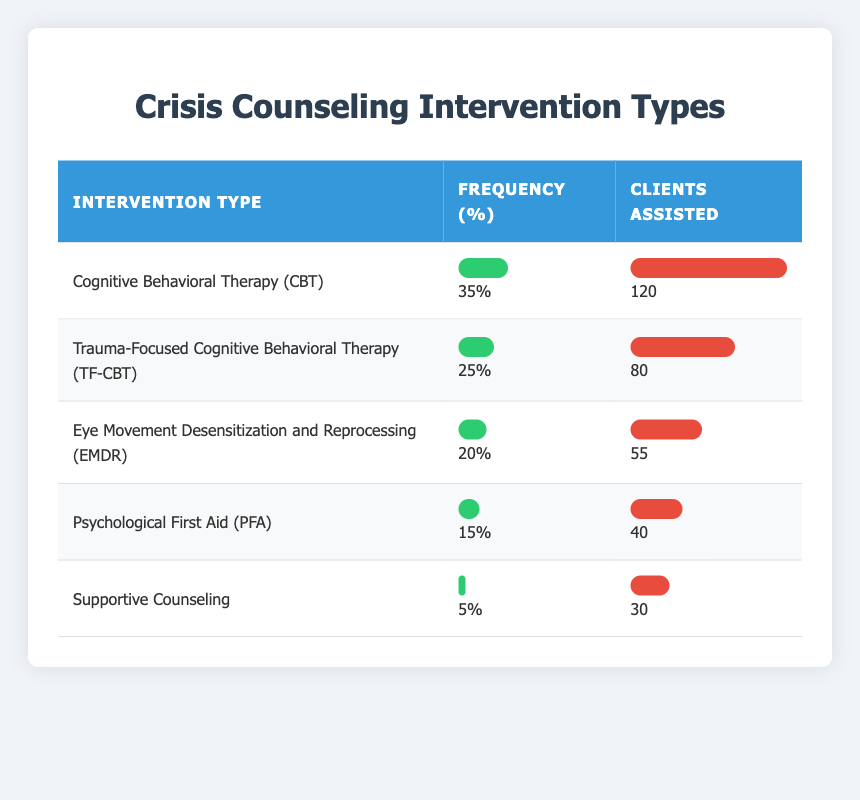What is the most frequently used intervention type? The table shows the frequency of each intervention type. Cognitive Behavioral Therapy (CBT) has the highest frequency of 35%.
Answer: Cognitive Behavioral Therapy (CBT) How many clients were assisted by Eye Movement Desensitization and Reprocessing (EMDR)? The table lists the number of clients assisted for each intervention type. EMDR assisted 55 clients.
Answer: 55 Is Supportive Counseling used more frequently than Psychological First Aid (PFA)? The frequency for Supportive Counseling is 5% and for PFA is 15%. Since 5% is less than 15%, it means Supportive Counseling is not used more frequently.
Answer: No What percentage of clients were assisted by Trauma-Focused Cognitive Behavioral Therapy (TF-CBT) relative to the total clients assisted? The total number of clients assisted is 120 + 80 + 55 + 40 + 30 = 325. TF-CBT assisted 80 clients. To find the percentage, calculate (80 / 325) * 100, which equals approximately 24.6%.
Answer: Approximately 24.6% Which intervention type assisted the least number of clients and how many? By comparing the clients assisted across all intervention types, Supportive Counseling assisted the least number of clients, which is 30.
Answer: Supportive Counseling, 30 